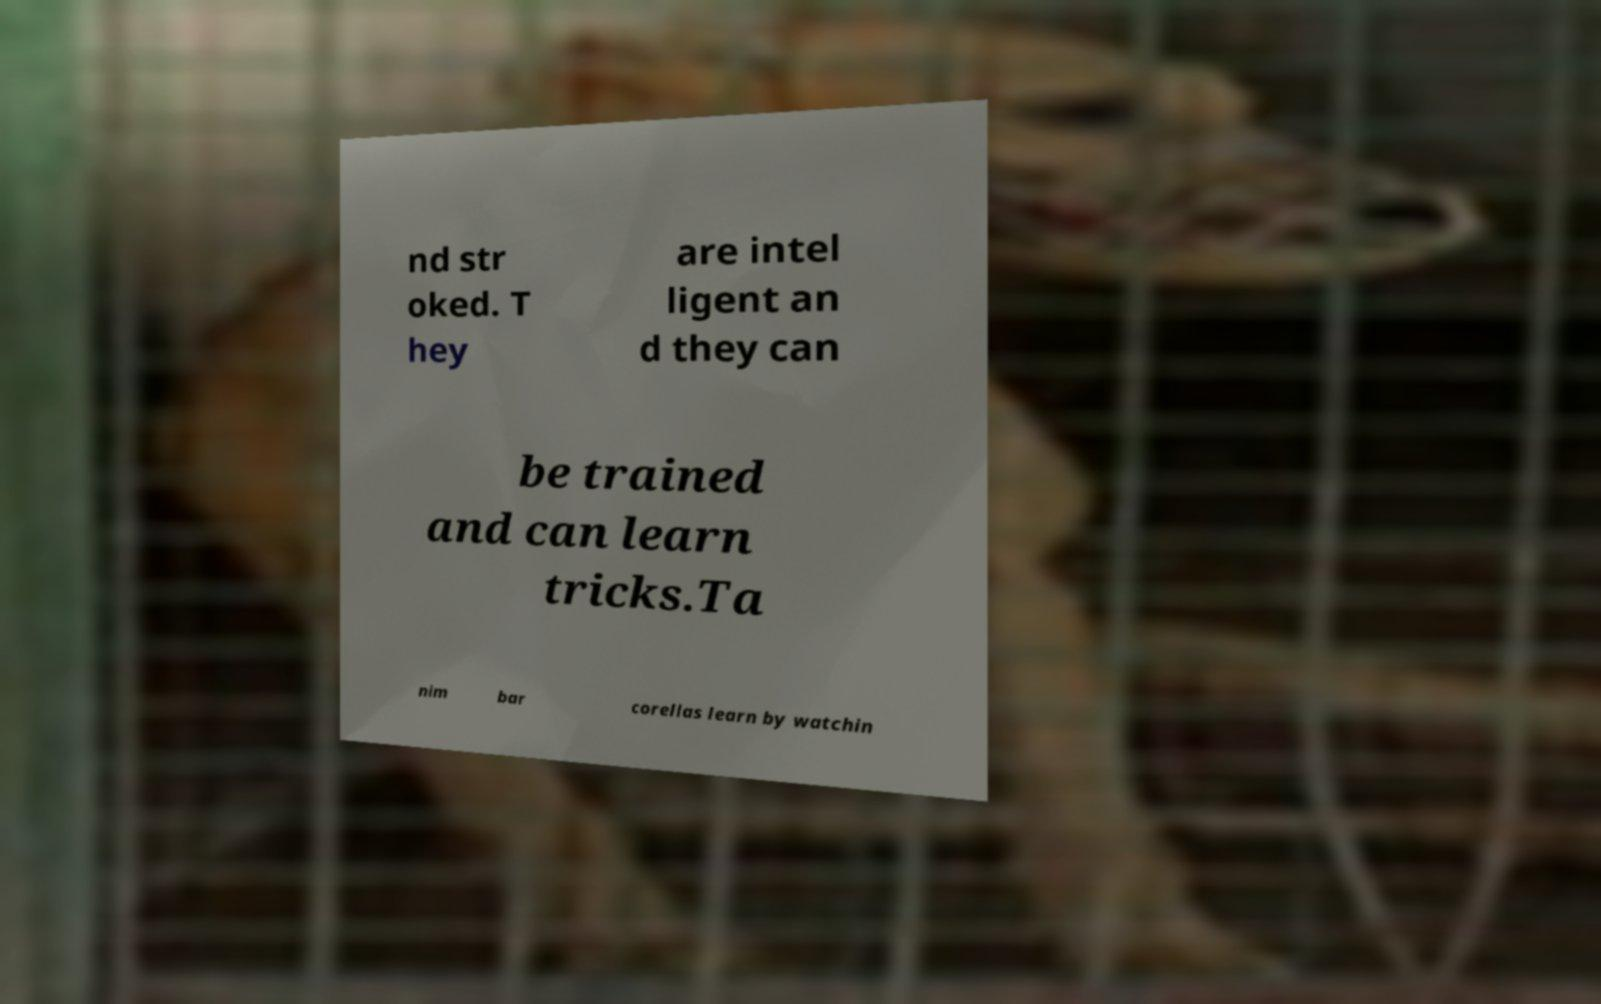Can you read and provide the text displayed in the image?This photo seems to have some interesting text. Can you extract and type it out for me? nd str oked. T hey are intel ligent an d they can be trained and can learn tricks.Ta nim bar corellas learn by watchin 